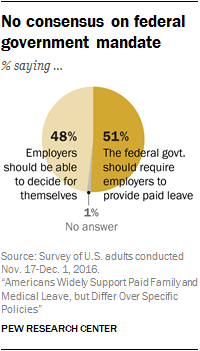Indicate a few pertinent items in this graphic. The percentage of respondents who chose the "Agree" option in the Likert scale question is represented by a grey color in the pie chart, with the value ranging from 0% to 100%. The Federal government should require employers to provide paid leave, while allowing employers to decide for themselves. 